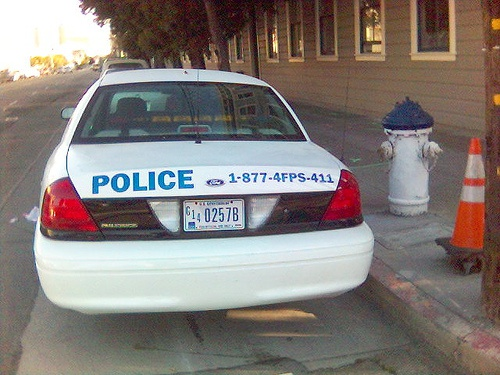Describe the objects in this image and their specific colors. I can see car in white, lightgray, gray, lightblue, and black tones, fire hydrant in white, darkgray, gray, and navy tones, car in white, gray, and darkgray tones, car in white, tan, and gray tones, and car in white, lightgray, and darkgray tones in this image. 